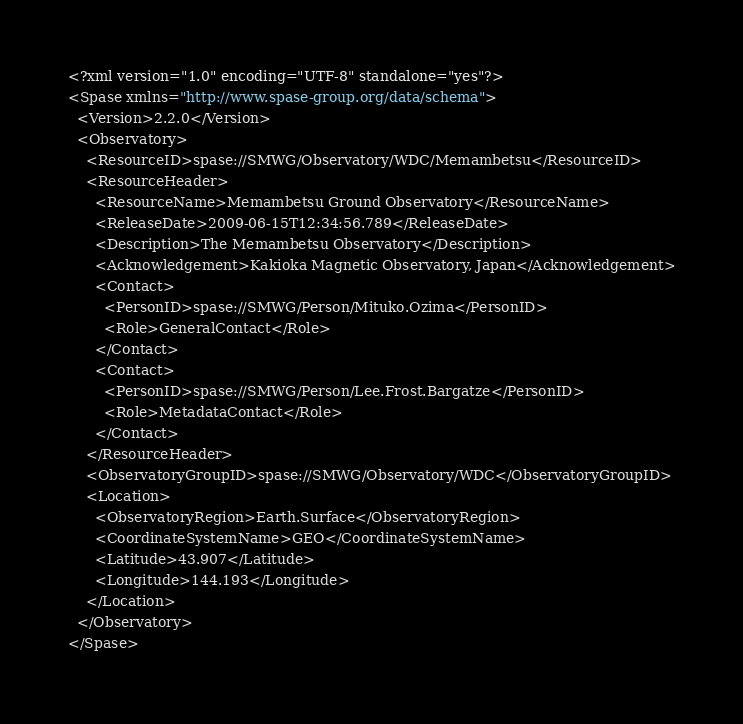Convert code to text. <code><loc_0><loc_0><loc_500><loc_500><_XML_><?xml version="1.0" encoding="UTF-8" standalone="yes"?>
<Spase xmlns="http://www.spase-group.org/data/schema">
  <Version>2.2.0</Version>
  <Observatory>
    <ResourceID>spase://SMWG/Observatory/WDC/Memambetsu</ResourceID>
    <ResourceHeader>
      <ResourceName>Memambetsu Ground Observatory</ResourceName>
      <ReleaseDate>2009-06-15T12:34:56.789</ReleaseDate>
      <Description>The Memambetsu Observatory</Description>
      <Acknowledgement>Kakioka Magnetic Observatory, Japan</Acknowledgement>
      <Contact>
        <PersonID>spase://SMWG/Person/Mituko.Ozima</PersonID>
        <Role>GeneralContact</Role>
      </Contact>
      <Contact>
        <PersonID>spase://SMWG/Person/Lee.Frost.Bargatze</PersonID>
        <Role>MetadataContact</Role>
      </Contact>
    </ResourceHeader>
    <ObservatoryGroupID>spase://SMWG/Observatory/WDC</ObservatoryGroupID>
    <Location>
      <ObservatoryRegion>Earth.Surface</ObservatoryRegion>
      <CoordinateSystemName>GEO</CoordinateSystemName>
      <Latitude>43.907</Latitude>
      <Longitude>144.193</Longitude>
    </Location>
  </Observatory>
</Spase>
</code> 